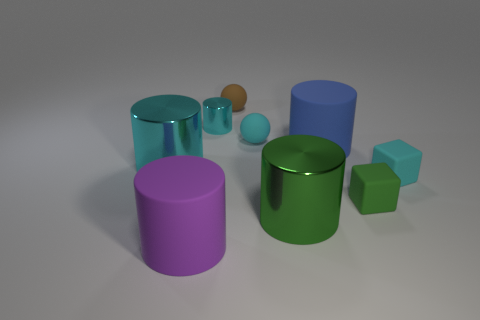How many objects are either small rubber balls that are in front of the small brown thing or big gray shiny objects?
Offer a very short reply. 1. Is the number of green matte cubes that are on the right side of the green metallic object the same as the number of things that are behind the purple matte thing?
Keep it short and to the point. No. There is a ball behind the small cyan metallic object that is behind the small block that is in front of the tiny cyan cube; what is its material?
Your response must be concise. Rubber. There is a matte object that is both in front of the cyan cube and on the right side of the cyan rubber sphere; how big is it?
Your answer should be compact. Small. Do the large purple matte thing and the large green thing have the same shape?
Keep it short and to the point. Yes. There is a green thing that is made of the same material as the big blue cylinder; what shape is it?
Keep it short and to the point. Cube. What number of tiny objects are either cyan cylinders or green metal things?
Offer a terse response. 1. Is there a cyan rubber object that is in front of the large metal cylinder that is left of the big green object?
Offer a terse response. Yes. Is there a cyan shiny object?
Offer a terse response. Yes. What is the color of the shiny thing to the left of the matte object that is on the left side of the tiny cyan cylinder?
Provide a short and direct response. Cyan. 